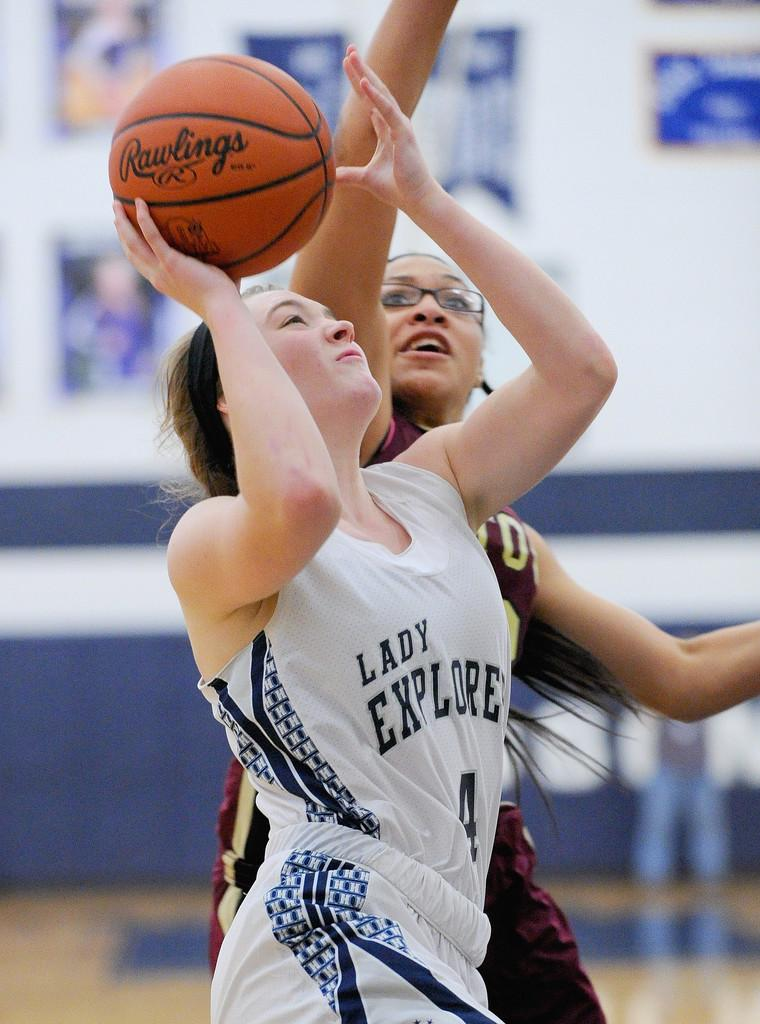<image>
Share a concise interpretation of the image provided. Two women play basketball with a Rawlings ball. 